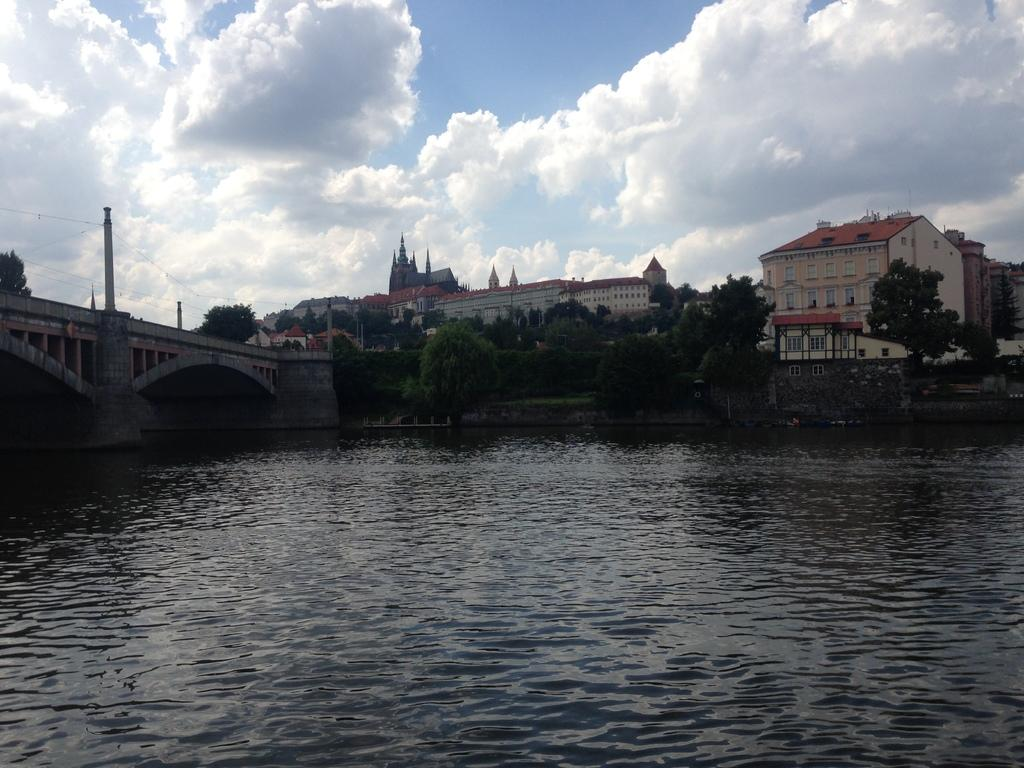What type of structures can be seen in the image? There are buildings in the image. What connects the two sides of the water in the image? There is a bridge in the image. What is attached to the bridge? Wires are attached to the bridge. What type of vegetation is present in the image? There are trees in the image. What can be seen in the water in the image? There is water visible in the image. What is the condition of the sky in the image? The sky is cloudy in the image. How much money is being exchanged on the bridge in the image? There is no indication of money being exchanged in the image; it features a bridge with wires attached. Can you see any ghosts in the image? There are no ghosts present in the image; it features buildings, a bridge, trees, water, and a cloudy sky. 